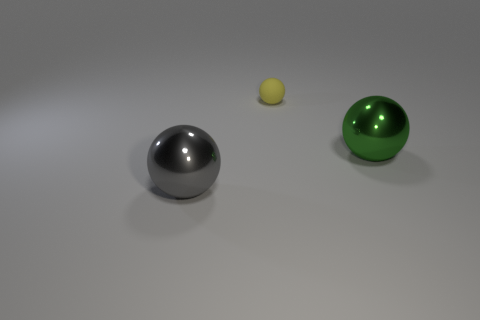Is there any other thing that is the same size as the yellow rubber thing?
Make the answer very short. No. Is there anything else that has the same material as the tiny sphere?
Provide a short and direct response. No. What number of gray objects are in front of the ball that is left of the tiny yellow ball?
Your answer should be very brief. 0. What size is the green thing that is the same material as the big gray sphere?
Ensure brevity in your answer.  Large. What size is the yellow rubber thing?
Keep it short and to the point. Small. Is the material of the small thing the same as the green thing?
Offer a terse response. No. What number of spheres are gray objects or matte things?
Give a very brief answer. 2. The sphere behind the big metallic object behind the big gray object is what color?
Offer a terse response. Yellow. How many big gray balls are in front of the big object to the right of the shiny object that is on the left side of the tiny yellow matte ball?
Provide a short and direct response. 1. Is the shape of the thing that is on the left side of the yellow matte sphere the same as the metal thing behind the gray metal thing?
Offer a terse response. Yes. 